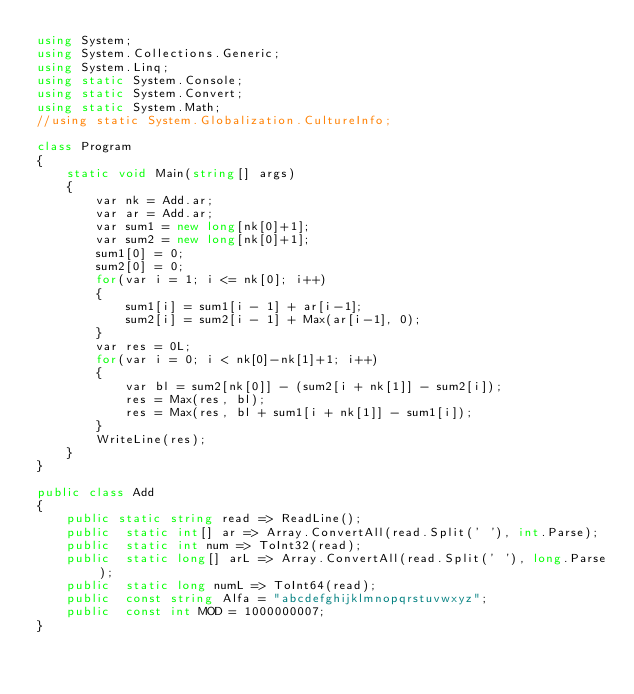Convert code to text. <code><loc_0><loc_0><loc_500><loc_500><_C#_>using System;
using System.Collections.Generic;
using System.Linq;
using static System.Console;
using static System.Convert;
using static System.Math;
//using static System.Globalization.CultureInfo;

class Program
{
    static void Main(string[] args)
    {
        var nk = Add.ar;
        var ar = Add.ar;
        var sum1 = new long[nk[0]+1];
        var sum2 = new long[nk[0]+1];
        sum1[0] = 0;
        sum2[0] = 0;
        for(var i = 1; i <= nk[0]; i++)
        {
            sum1[i] = sum1[i - 1] + ar[i-1];
            sum2[i] = sum2[i - 1] + Max(ar[i-1], 0);
        }
        var res = 0L;
        for(var i = 0; i < nk[0]-nk[1]+1; i++)
        {
            var bl = sum2[nk[0]] - (sum2[i + nk[1]] - sum2[i]);
            res = Max(res, bl);
            res = Max(res, bl + sum1[i + nk[1]] - sum1[i]);
        }
        WriteLine(res);
    }
}

public class Add
{
    public static string read => ReadLine();
    public  static int[] ar => Array.ConvertAll(read.Split(' '), int.Parse);
    public  static int num => ToInt32(read);
    public  static long[] arL => Array.ConvertAll(read.Split(' '), long.Parse);
    public  static long numL => ToInt64(read);
    public  const string Alfa = "abcdefghijklmnopqrstuvwxyz";
    public  const int MOD = 1000000007;
}
</code> 